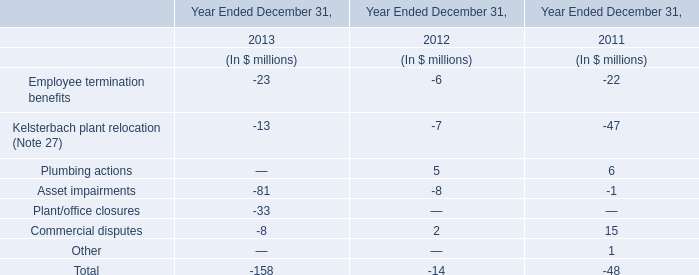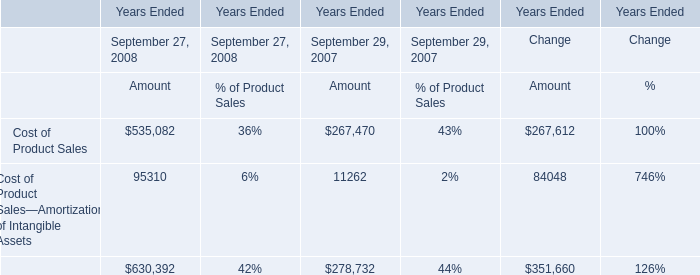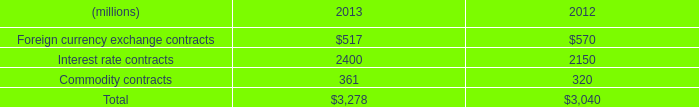What's the sum of Cost of Product Sales of Years Ended Change Amount, Interest rate contracts of 2013, and total of Years Ended September 29, 2007 Amount ? 
Computations: ((267612.0 + 2400.0) + 278732.0)
Answer: 548744.0. 